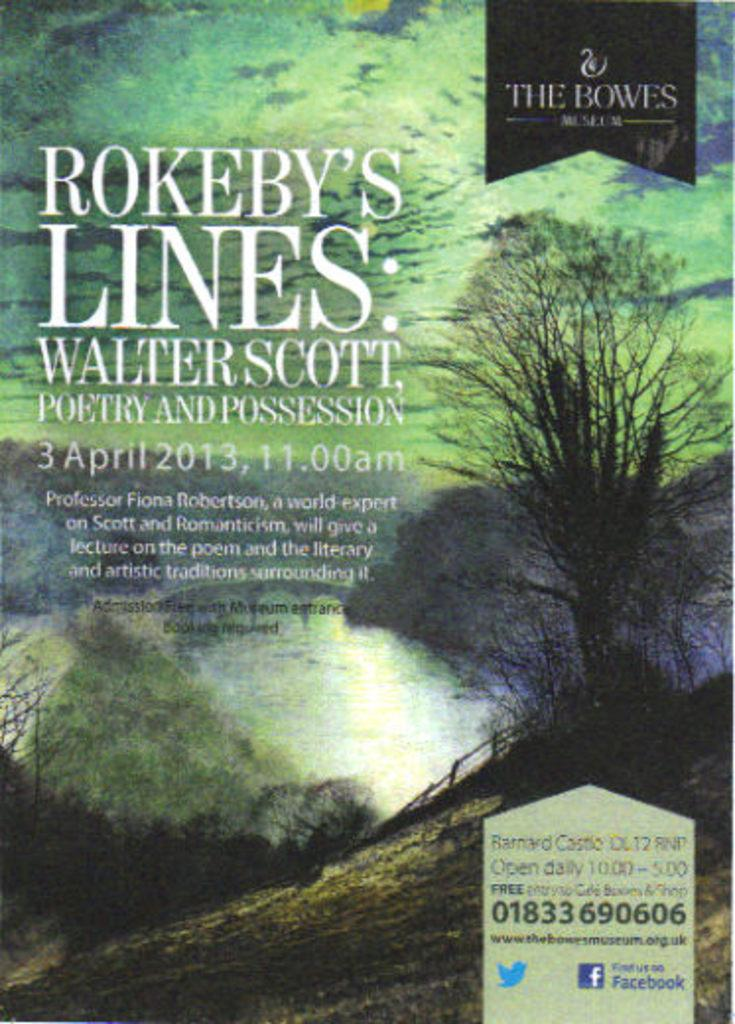<image>
Create a compact narrative representing the image presented. A book is entitled "Rokeby's Lines: Watler Scott Poetry and Possession." 